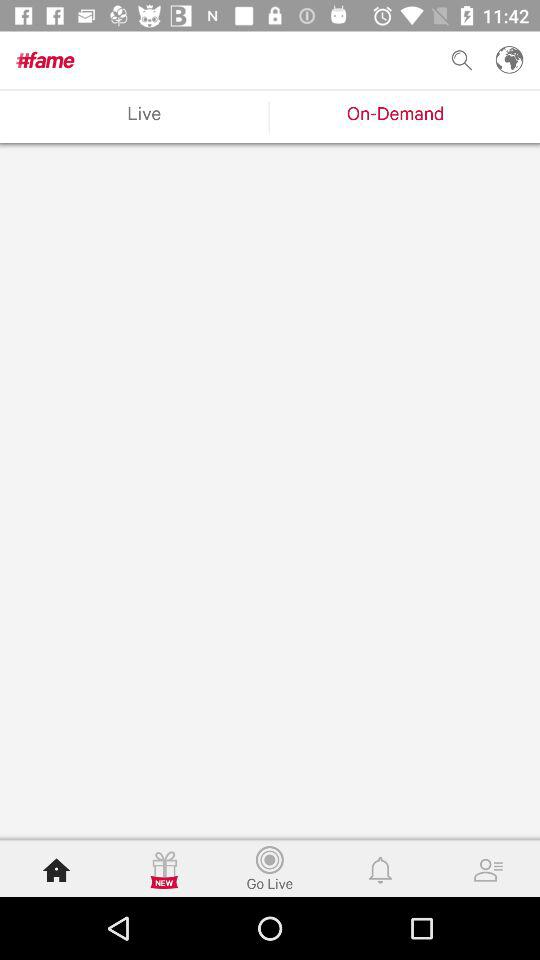Which tab is selected? The selected tabs are "On-Demand" an d "Home". 